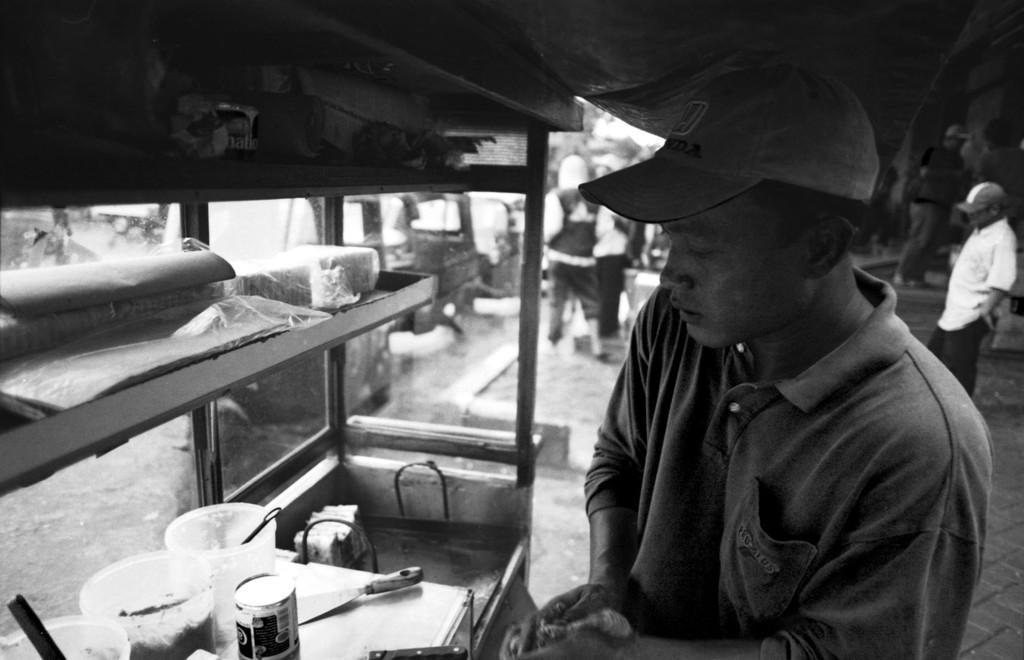Please provide a concise description of this image. This is black and white image where we can see a man. He is wearing t-shirt and cap. In front of the man, one stall is there and things are arranged. Background of the image, people and vehicles are there on the road. 